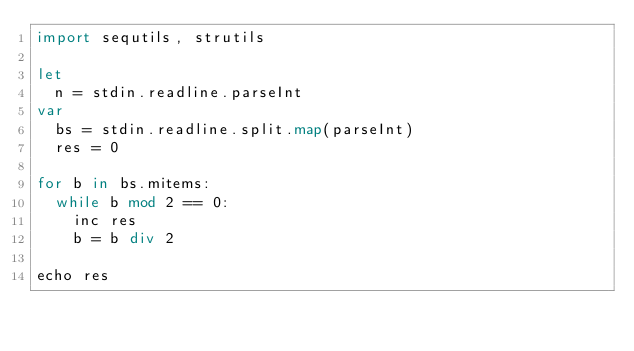Convert code to text. <code><loc_0><loc_0><loc_500><loc_500><_Nim_>import sequtils, strutils

let
  n = stdin.readline.parseInt
var
  bs = stdin.readline.split.map(parseInt)
  res = 0

for b in bs.mitems:
  while b mod 2 == 0:
    inc res
    b = b div 2

echo res
</code> 